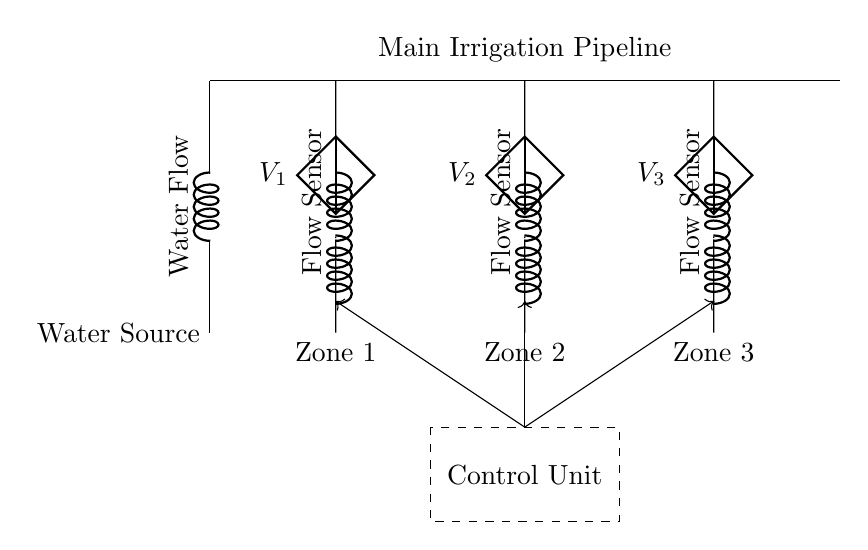What are the three zones represented in the circuit? The circuit features three irrigation zones labeled as Zone 1, Zone 2, and Zone 3 located at the respective parallel branches.
Answer: Zone 1, Zone 2, Zone 3 What is the function of the control unit in the circuit? The control unit coordinates the flow signals to each zone by regulating the control valves based on input from sensors, allowing for efficient water management.
Answer: Control signals What is connected to each zone in the irrigation system? Each zone has a control valve and a flow sensor to manage and monitor the water flow, which includes regulating the amount of water supplied to the irrigation zones.
Answer: Control valve and flow sensor What does the label V_1 indicate in the circuit? The label V_1 denotes the voltage across the control valve for Zone 1, representing the potential difference needed to operate the valve and manage flow in that zone.
Answer: V_1 What would happen if one zone's control valve fails? In a parallel circuit, failure of one zone's control valve would not affect the operation of other zones, allowing them to remain functional independently, demonstrating the resilience of parallel configurations.
Answer: Other zones remain functional How is water flow monitored in each zone of the circuit? Each zone is equipped with a flow sensor that detects and reports the flow rate of water, allowing for effective irrigation management based on real-time flow data.
Answer: Flow sensor 